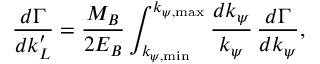<formula> <loc_0><loc_0><loc_500><loc_500>\frac { d \Gamma } { d k _ { L } ^ { \prime } } = \frac { M _ { B } } { 2 E _ { B } } \int _ { k _ { \psi , \min } } ^ { k _ { \psi , \max } } \frac { d k _ { \psi } } { k _ { \psi } } \, \frac { d \Gamma } { d k _ { \psi } } ,</formula> 